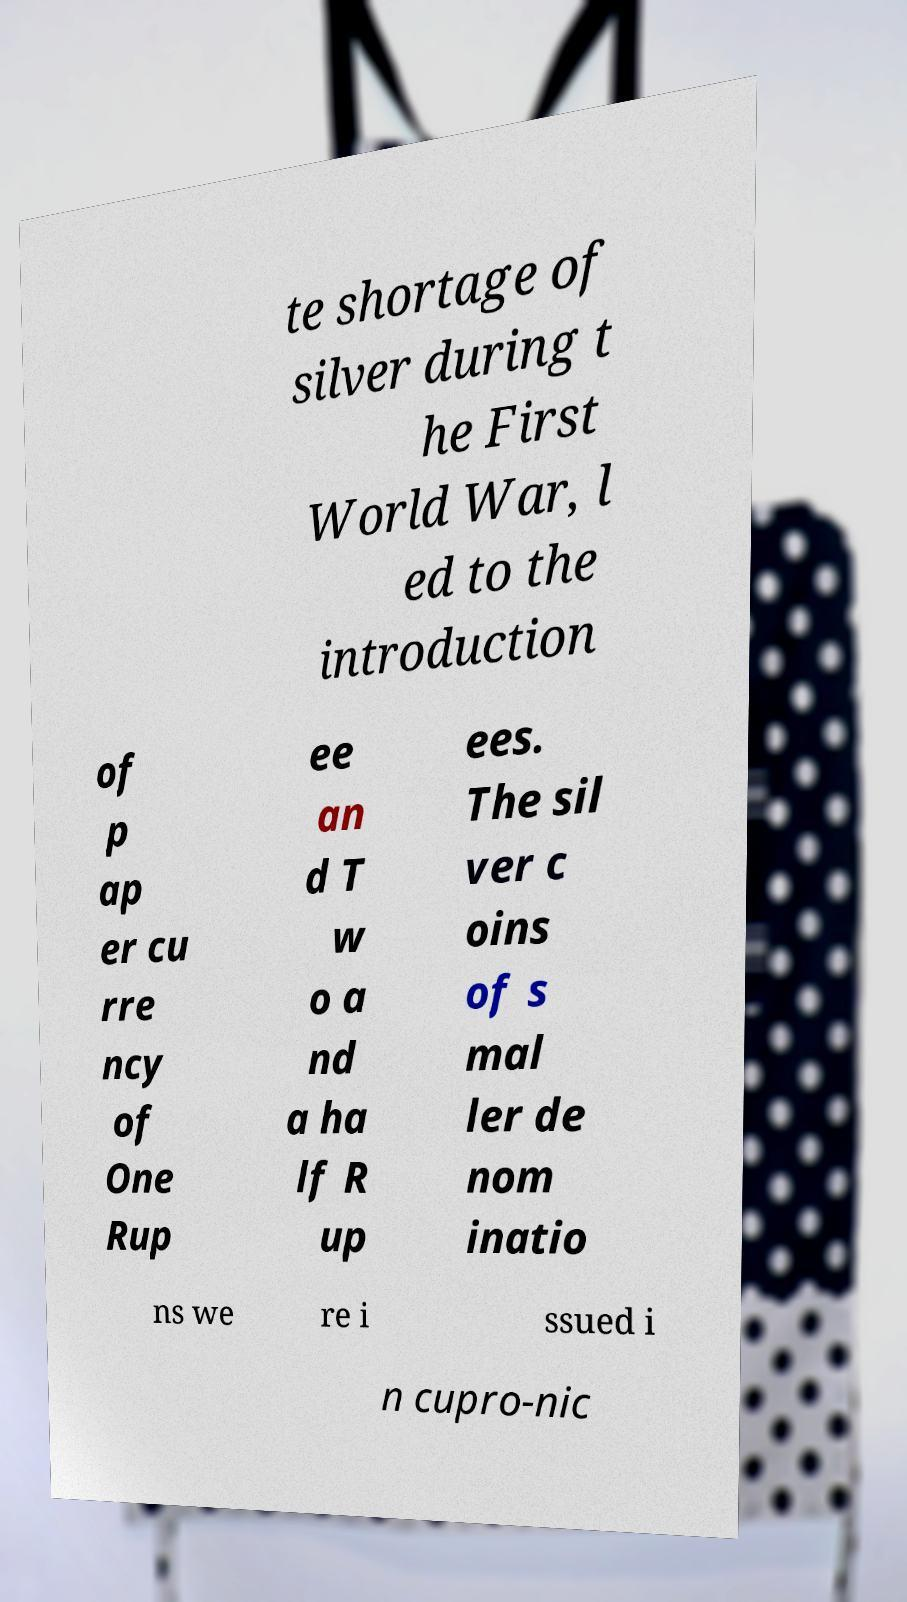Can you read and provide the text displayed in the image?This photo seems to have some interesting text. Can you extract and type it out for me? te shortage of silver during t he First World War, l ed to the introduction of p ap er cu rre ncy of One Rup ee an d T w o a nd a ha lf R up ees. The sil ver c oins of s mal ler de nom inatio ns we re i ssued i n cupro-nic 